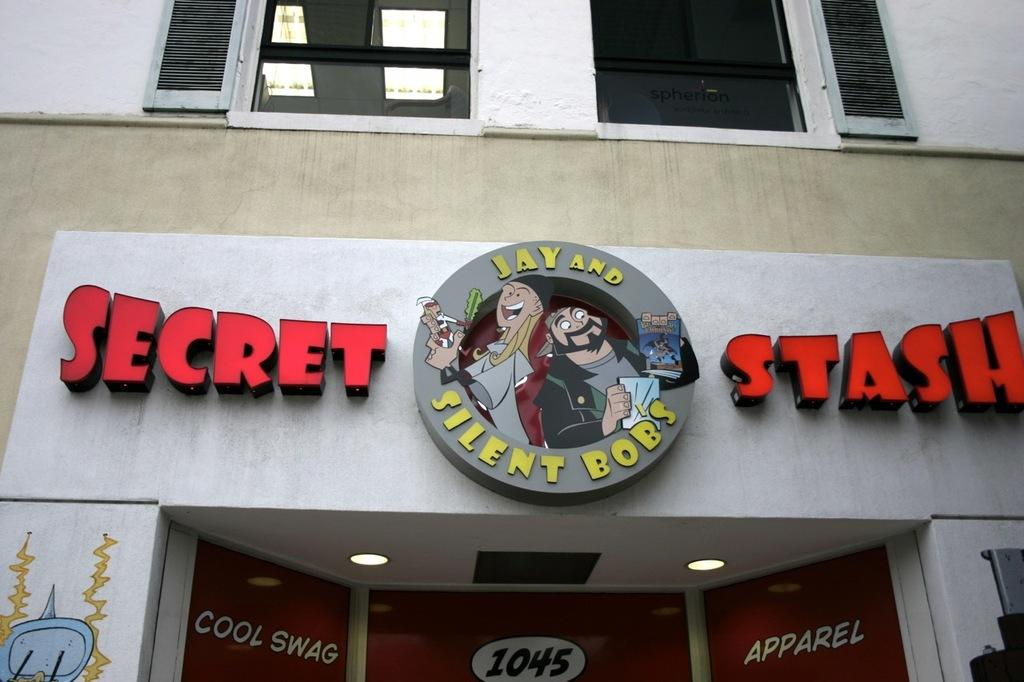Provide a one-sentence caption for the provided image. A shop's logo features the characters Jay and Silent Bob. 